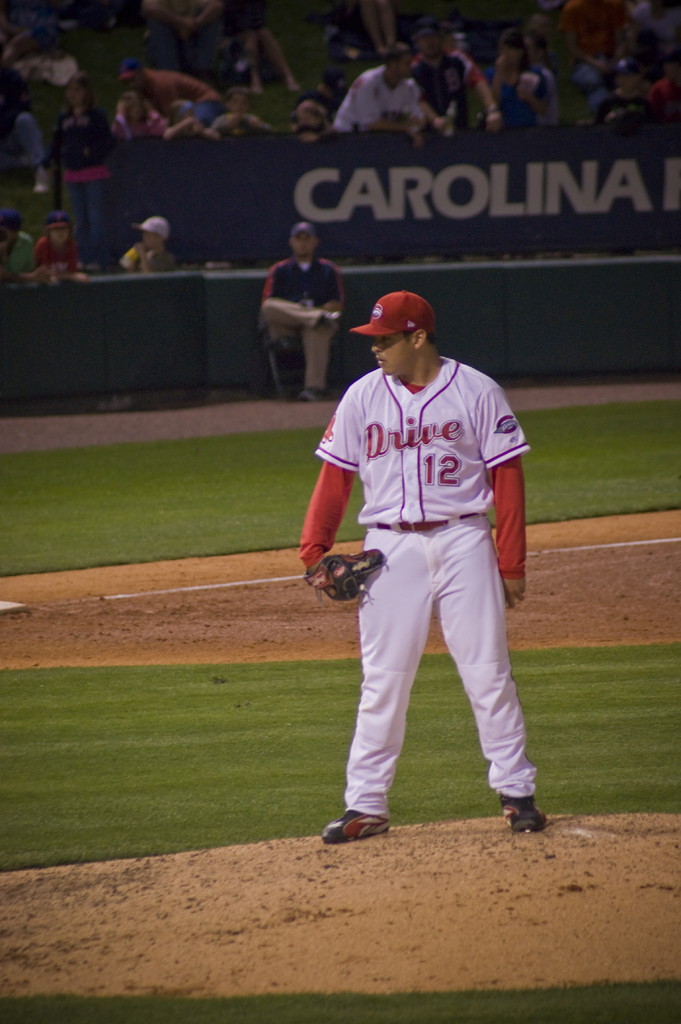What mood does the image evoke and how does the player contribute to it? The image evokes a mood of intense concentration and suspense typical of moments before a pitch in baseball. The player's focused demeanor, along with the stadium's vibrant, yet subdued lighting, enhances this dramatic atmosphere. 